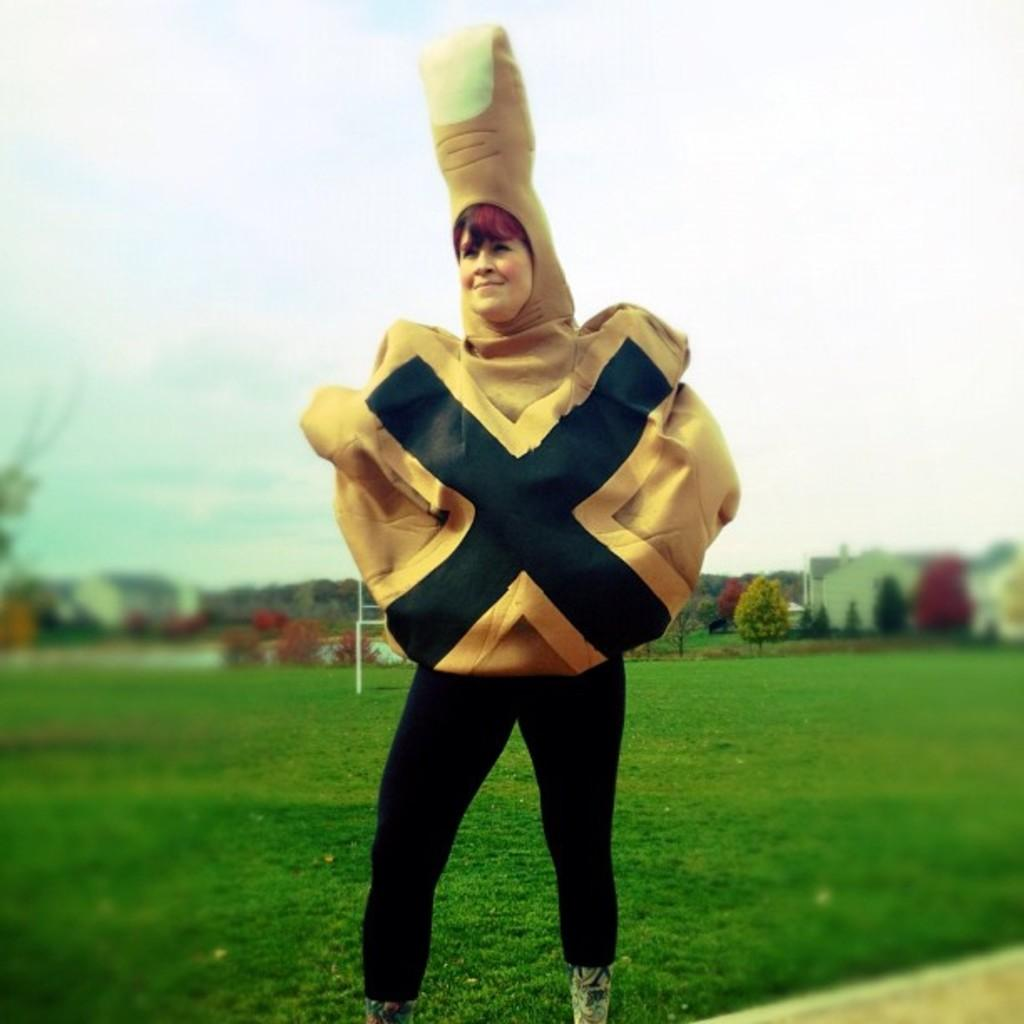What is the person in the image doing? The person is standing on the grass in the image. What is the person wearing? The person is wearing a drama costume. What can be seen in the background of the image? Trees are visible in the background of the image, along with other unspecified elements. How does the person in the image generate power during the rainstorm? There is no rainstorm present in the image, and the person is not generating power. 